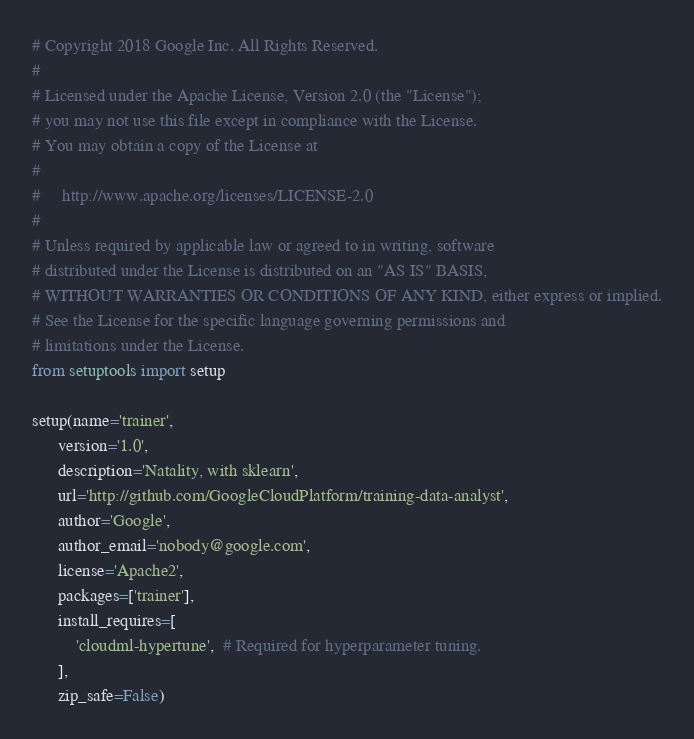<code> <loc_0><loc_0><loc_500><loc_500><_Python_># Copyright 2018 Google Inc. All Rights Reserved.
#
# Licensed under the Apache License, Version 2.0 (the "License");
# you may not use this file except in compliance with the License.
# You may obtain a copy of the License at
#
#     http://www.apache.org/licenses/LICENSE-2.0
#
# Unless required by applicable law or agreed to in writing, software
# distributed under the License is distributed on an "AS IS" BASIS,
# WITHOUT WARRANTIES OR CONDITIONS OF ANY KIND, either express or implied.
# See the License for the specific language governing permissions and
# limitations under the License.
from setuptools import setup

setup(name='trainer',
      version='1.0',
      description='Natality, with sklearn',
      url='http://github.com/GoogleCloudPlatform/training-data-analyst',
      author='Google',
      author_email='nobody@google.com',
      license='Apache2',
      packages=['trainer'],
      install_requires=[
          'cloudml-hypertune',  # Required for hyperparameter tuning.
      ],
      zip_safe=False)
</code> 